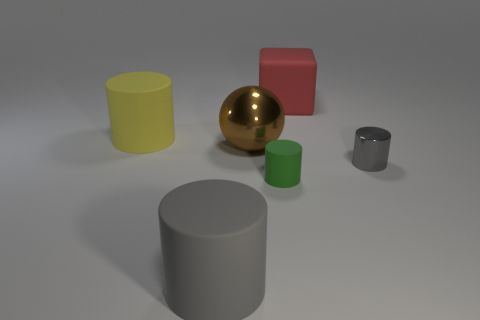What number of objects are either big purple matte balls or cylinders?
Your answer should be very brief. 4. The green rubber object that is the same shape as the small gray thing is what size?
Offer a very short reply. Small. Is the number of big brown metal spheres in front of the small green rubber object greater than the number of red rubber spheres?
Your answer should be very brief. No. Is the big gray cylinder made of the same material as the brown thing?
Ensure brevity in your answer.  No. How many objects are big matte objects behind the gray metallic object or rubber cylinders in front of the big shiny sphere?
Your response must be concise. 4. What is the color of the other tiny metallic object that is the same shape as the green thing?
Provide a succinct answer. Gray. What number of things are the same color as the shiny cylinder?
Your response must be concise. 1. Do the small rubber object and the large metal ball have the same color?
Your answer should be compact. No. How many things are either gray cylinders that are behind the large gray rubber thing or large gray rubber objects?
Your answer should be very brief. 2. The cylinder behind the gray cylinder on the right side of the big matte object in front of the tiny gray cylinder is what color?
Your response must be concise. Yellow. 